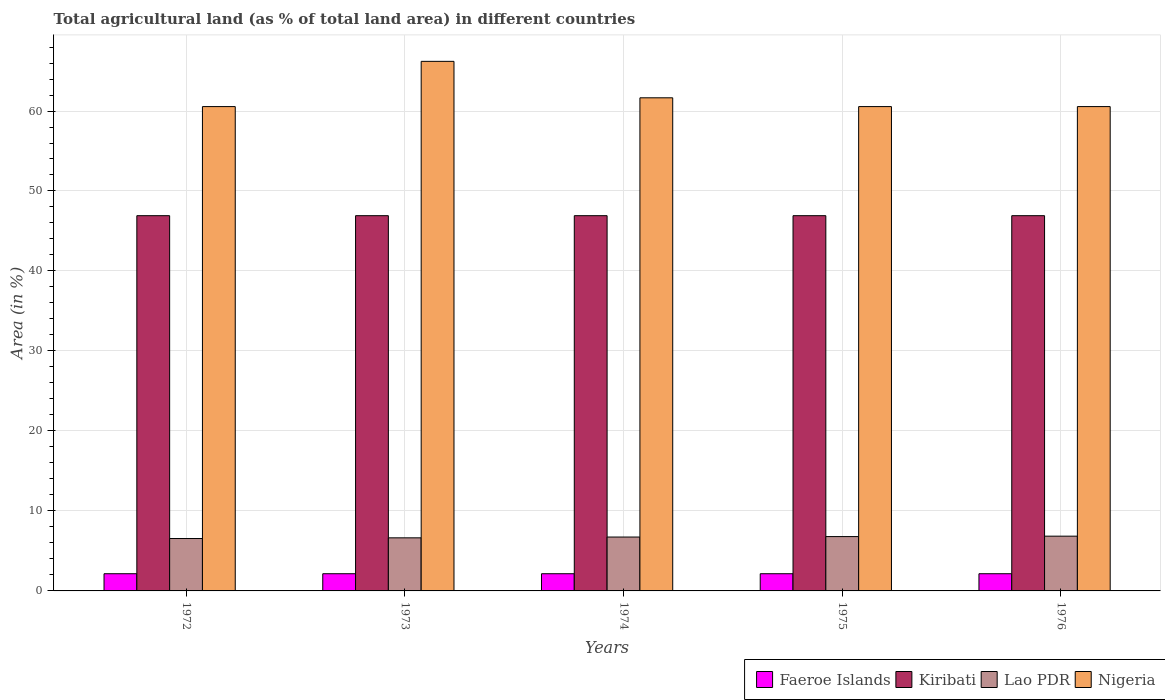How many different coloured bars are there?
Your response must be concise. 4. How many groups of bars are there?
Give a very brief answer. 5. What is the percentage of agricultural land in Lao PDR in 1976?
Provide a succinct answer. 6.85. Across all years, what is the maximum percentage of agricultural land in Faeroe Islands?
Your answer should be compact. 2.15. Across all years, what is the minimum percentage of agricultural land in Lao PDR?
Ensure brevity in your answer.  6.55. In which year was the percentage of agricultural land in Lao PDR maximum?
Provide a short and direct response. 1976. What is the total percentage of agricultural land in Kiribati in the graph?
Make the answer very short. 234.57. What is the difference between the percentage of agricultural land in Lao PDR in 1972 and that in 1976?
Provide a short and direct response. -0.29. What is the difference between the percentage of agricultural land in Kiribati in 1976 and the percentage of agricultural land in Faeroe Islands in 1974?
Provide a succinct answer. 44.76. What is the average percentage of agricultural land in Nigeria per year?
Give a very brief answer. 61.9. In the year 1972, what is the difference between the percentage of agricultural land in Faeroe Islands and percentage of agricultural land in Lao PDR?
Your answer should be compact. -4.4. What is the ratio of the percentage of agricultural land in Lao PDR in 1974 to that in 1976?
Keep it short and to the point. 0.98. Is the percentage of agricultural land in Lao PDR in 1975 less than that in 1976?
Provide a short and direct response. Yes. Is the difference between the percentage of agricultural land in Faeroe Islands in 1972 and 1974 greater than the difference between the percentage of agricultural land in Lao PDR in 1972 and 1974?
Provide a succinct answer. Yes. What is the difference between the highest and the second highest percentage of agricultural land in Lao PDR?
Your response must be concise. 0.05. What is the difference between the highest and the lowest percentage of agricultural land in Kiribati?
Give a very brief answer. 0. In how many years, is the percentage of agricultural land in Kiribati greater than the average percentage of agricultural land in Kiribati taken over all years?
Provide a short and direct response. 0. Is the sum of the percentage of agricultural land in Nigeria in 1973 and 1974 greater than the maximum percentage of agricultural land in Lao PDR across all years?
Provide a short and direct response. Yes. What does the 1st bar from the left in 1972 represents?
Give a very brief answer. Faeroe Islands. What does the 4th bar from the right in 1974 represents?
Your response must be concise. Faeroe Islands. Is it the case that in every year, the sum of the percentage of agricultural land in Lao PDR and percentage of agricultural land in Nigeria is greater than the percentage of agricultural land in Faeroe Islands?
Your response must be concise. Yes. What is the difference between two consecutive major ticks on the Y-axis?
Ensure brevity in your answer.  10. Does the graph contain grids?
Keep it short and to the point. Yes. What is the title of the graph?
Provide a short and direct response. Total agricultural land (as % of total land area) in different countries. What is the label or title of the Y-axis?
Your response must be concise. Area (in %). What is the Area (in %) of Faeroe Islands in 1972?
Make the answer very short. 2.15. What is the Area (in %) of Kiribati in 1972?
Your answer should be very brief. 46.91. What is the Area (in %) of Lao PDR in 1972?
Provide a short and direct response. 6.55. What is the Area (in %) in Nigeria in 1972?
Provide a short and direct response. 60.55. What is the Area (in %) of Faeroe Islands in 1973?
Give a very brief answer. 2.15. What is the Area (in %) of Kiribati in 1973?
Ensure brevity in your answer.  46.91. What is the Area (in %) in Lao PDR in 1973?
Your response must be concise. 6.64. What is the Area (in %) in Nigeria in 1973?
Offer a terse response. 66.21. What is the Area (in %) in Faeroe Islands in 1974?
Provide a short and direct response. 2.15. What is the Area (in %) in Kiribati in 1974?
Your answer should be compact. 46.91. What is the Area (in %) of Lao PDR in 1974?
Offer a terse response. 6.74. What is the Area (in %) of Nigeria in 1974?
Keep it short and to the point. 61.65. What is the Area (in %) in Faeroe Islands in 1975?
Your answer should be very brief. 2.15. What is the Area (in %) in Kiribati in 1975?
Provide a short and direct response. 46.91. What is the Area (in %) of Lao PDR in 1975?
Your answer should be compact. 6.79. What is the Area (in %) in Nigeria in 1975?
Provide a short and direct response. 60.55. What is the Area (in %) in Faeroe Islands in 1976?
Give a very brief answer. 2.15. What is the Area (in %) of Kiribati in 1976?
Your answer should be compact. 46.91. What is the Area (in %) in Lao PDR in 1976?
Your response must be concise. 6.85. What is the Area (in %) of Nigeria in 1976?
Give a very brief answer. 60.55. Across all years, what is the maximum Area (in %) of Faeroe Islands?
Give a very brief answer. 2.15. Across all years, what is the maximum Area (in %) of Kiribati?
Make the answer very short. 46.91. Across all years, what is the maximum Area (in %) in Lao PDR?
Ensure brevity in your answer.  6.85. Across all years, what is the maximum Area (in %) in Nigeria?
Keep it short and to the point. 66.21. Across all years, what is the minimum Area (in %) in Faeroe Islands?
Keep it short and to the point. 2.15. Across all years, what is the minimum Area (in %) in Kiribati?
Keep it short and to the point. 46.91. Across all years, what is the minimum Area (in %) of Lao PDR?
Keep it short and to the point. 6.55. Across all years, what is the minimum Area (in %) in Nigeria?
Provide a succinct answer. 60.55. What is the total Area (in %) of Faeroe Islands in the graph?
Offer a very short reply. 10.74. What is the total Area (in %) of Kiribati in the graph?
Provide a short and direct response. 234.57. What is the total Area (in %) of Lao PDR in the graph?
Offer a very short reply. 33.57. What is the total Area (in %) of Nigeria in the graph?
Provide a short and direct response. 309.52. What is the difference between the Area (in %) in Faeroe Islands in 1972 and that in 1973?
Give a very brief answer. 0. What is the difference between the Area (in %) of Lao PDR in 1972 and that in 1973?
Provide a succinct answer. -0.09. What is the difference between the Area (in %) of Nigeria in 1972 and that in 1973?
Offer a very short reply. -5.65. What is the difference between the Area (in %) of Lao PDR in 1972 and that in 1974?
Offer a terse response. -0.19. What is the difference between the Area (in %) of Nigeria in 1972 and that in 1974?
Offer a very short reply. -1.1. What is the difference between the Area (in %) of Kiribati in 1972 and that in 1975?
Provide a short and direct response. 0. What is the difference between the Area (in %) in Lao PDR in 1972 and that in 1975?
Your response must be concise. -0.24. What is the difference between the Area (in %) in Nigeria in 1972 and that in 1975?
Offer a very short reply. 0. What is the difference between the Area (in %) of Kiribati in 1972 and that in 1976?
Your answer should be very brief. 0. What is the difference between the Area (in %) of Lao PDR in 1972 and that in 1976?
Provide a succinct answer. -0.29. What is the difference between the Area (in %) in Nigeria in 1972 and that in 1976?
Make the answer very short. 0. What is the difference between the Area (in %) of Kiribati in 1973 and that in 1974?
Offer a terse response. 0. What is the difference between the Area (in %) of Lao PDR in 1973 and that in 1974?
Make the answer very short. -0.1. What is the difference between the Area (in %) of Nigeria in 1973 and that in 1974?
Ensure brevity in your answer.  4.56. What is the difference between the Area (in %) of Lao PDR in 1973 and that in 1975?
Your response must be concise. -0.16. What is the difference between the Area (in %) of Nigeria in 1973 and that in 1975?
Offer a very short reply. 5.65. What is the difference between the Area (in %) in Lao PDR in 1973 and that in 1976?
Keep it short and to the point. -0.21. What is the difference between the Area (in %) of Nigeria in 1973 and that in 1976?
Offer a very short reply. 5.65. What is the difference between the Area (in %) of Lao PDR in 1974 and that in 1975?
Offer a terse response. -0.06. What is the difference between the Area (in %) in Nigeria in 1974 and that in 1975?
Offer a terse response. 1.1. What is the difference between the Area (in %) in Faeroe Islands in 1974 and that in 1976?
Your response must be concise. 0. What is the difference between the Area (in %) in Kiribati in 1974 and that in 1976?
Ensure brevity in your answer.  0. What is the difference between the Area (in %) of Lao PDR in 1974 and that in 1976?
Make the answer very short. -0.11. What is the difference between the Area (in %) in Nigeria in 1974 and that in 1976?
Keep it short and to the point. 1.1. What is the difference between the Area (in %) of Kiribati in 1975 and that in 1976?
Offer a very short reply. 0. What is the difference between the Area (in %) in Lao PDR in 1975 and that in 1976?
Keep it short and to the point. -0.05. What is the difference between the Area (in %) in Faeroe Islands in 1972 and the Area (in %) in Kiribati in 1973?
Give a very brief answer. -44.76. What is the difference between the Area (in %) in Faeroe Islands in 1972 and the Area (in %) in Lao PDR in 1973?
Offer a terse response. -4.49. What is the difference between the Area (in %) of Faeroe Islands in 1972 and the Area (in %) of Nigeria in 1973?
Give a very brief answer. -64.06. What is the difference between the Area (in %) in Kiribati in 1972 and the Area (in %) in Lao PDR in 1973?
Give a very brief answer. 40.28. What is the difference between the Area (in %) in Kiribati in 1972 and the Area (in %) in Nigeria in 1973?
Your response must be concise. -19.29. What is the difference between the Area (in %) of Lao PDR in 1972 and the Area (in %) of Nigeria in 1973?
Give a very brief answer. -59.66. What is the difference between the Area (in %) in Faeroe Islands in 1972 and the Area (in %) in Kiribati in 1974?
Provide a succinct answer. -44.76. What is the difference between the Area (in %) of Faeroe Islands in 1972 and the Area (in %) of Lao PDR in 1974?
Your answer should be compact. -4.59. What is the difference between the Area (in %) of Faeroe Islands in 1972 and the Area (in %) of Nigeria in 1974?
Provide a succinct answer. -59.5. What is the difference between the Area (in %) in Kiribati in 1972 and the Area (in %) in Lao PDR in 1974?
Provide a succinct answer. 40.18. What is the difference between the Area (in %) in Kiribati in 1972 and the Area (in %) in Nigeria in 1974?
Your answer should be very brief. -14.74. What is the difference between the Area (in %) in Lao PDR in 1972 and the Area (in %) in Nigeria in 1974?
Provide a succinct answer. -55.1. What is the difference between the Area (in %) in Faeroe Islands in 1972 and the Area (in %) in Kiribati in 1975?
Make the answer very short. -44.76. What is the difference between the Area (in %) in Faeroe Islands in 1972 and the Area (in %) in Lao PDR in 1975?
Keep it short and to the point. -4.64. What is the difference between the Area (in %) of Faeroe Islands in 1972 and the Area (in %) of Nigeria in 1975?
Your answer should be compact. -58.4. What is the difference between the Area (in %) in Kiribati in 1972 and the Area (in %) in Lao PDR in 1975?
Provide a succinct answer. 40.12. What is the difference between the Area (in %) in Kiribati in 1972 and the Area (in %) in Nigeria in 1975?
Offer a terse response. -13.64. What is the difference between the Area (in %) in Lao PDR in 1972 and the Area (in %) in Nigeria in 1975?
Keep it short and to the point. -54. What is the difference between the Area (in %) of Faeroe Islands in 1972 and the Area (in %) of Kiribati in 1976?
Offer a very short reply. -44.76. What is the difference between the Area (in %) in Faeroe Islands in 1972 and the Area (in %) in Lao PDR in 1976?
Ensure brevity in your answer.  -4.7. What is the difference between the Area (in %) of Faeroe Islands in 1972 and the Area (in %) of Nigeria in 1976?
Give a very brief answer. -58.4. What is the difference between the Area (in %) of Kiribati in 1972 and the Area (in %) of Lao PDR in 1976?
Your response must be concise. 40.07. What is the difference between the Area (in %) in Kiribati in 1972 and the Area (in %) in Nigeria in 1976?
Your answer should be very brief. -13.64. What is the difference between the Area (in %) in Lao PDR in 1972 and the Area (in %) in Nigeria in 1976?
Your answer should be compact. -54. What is the difference between the Area (in %) of Faeroe Islands in 1973 and the Area (in %) of Kiribati in 1974?
Give a very brief answer. -44.76. What is the difference between the Area (in %) in Faeroe Islands in 1973 and the Area (in %) in Lao PDR in 1974?
Give a very brief answer. -4.59. What is the difference between the Area (in %) in Faeroe Islands in 1973 and the Area (in %) in Nigeria in 1974?
Your answer should be very brief. -59.5. What is the difference between the Area (in %) of Kiribati in 1973 and the Area (in %) of Lao PDR in 1974?
Provide a succinct answer. 40.18. What is the difference between the Area (in %) of Kiribati in 1973 and the Area (in %) of Nigeria in 1974?
Your response must be concise. -14.74. What is the difference between the Area (in %) in Lao PDR in 1973 and the Area (in %) in Nigeria in 1974?
Give a very brief answer. -55.01. What is the difference between the Area (in %) in Faeroe Islands in 1973 and the Area (in %) in Kiribati in 1975?
Make the answer very short. -44.76. What is the difference between the Area (in %) of Faeroe Islands in 1973 and the Area (in %) of Lao PDR in 1975?
Your answer should be compact. -4.64. What is the difference between the Area (in %) in Faeroe Islands in 1973 and the Area (in %) in Nigeria in 1975?
Make the answer very short. -58.4. What is the difference between the Area (in %) of Kiribati in 1973 and the Area (in %) of Lao PDR in 1975?
Offer a terse response. 40.12. What is the difference between the Area (in %) in Kiribati in 1973 and the Area (in %) in Nigeria in 1975?
Keep it short and to the point. -13.64. What is the difference between the Area (in %) of Lao PDR in 1973 and the Area (in %) of Nigeria in 1975?
Your answer should be very brief. -53.92. What is the difference between the Area (in %) of Faeroe Islands in 1973 and the Area (in %) of Kiribati in 1976?
Your response must be concise. -44.76. What is the difference between the Area (in %) in Faeroe Islands in 1973 and the Area (in %) in Lao PDR in 1976?
Provide a short and direct response. -4.7. What is the difference between the Area (in %) in Faeroe Islands in 1973 and the Area (in %) in Nigeria in 1976?
Give a very brief answer. -58.4. What is the difference between the Area (in %) in Kiribati in 1973 and the Area (in %) in Lao PDR in 1976?
Your response must be concise. 40.07. What is the difference between the Area (in %) of Kiribati in 1973 and the Area (in %) of Nigeria in 1976?
Provide a short and direct response. -13.64. What is the difference between the Area (in %) of Lao PDR in 1973 and the Area (in %) of Nigeria in 1976?
Ensure brevity in your answer.  -53.92. What is the difference between the Area (in %) in Faeroe Islands in 1974 and the Area (in %) in Kiribati in 1975?
Your response must be concise. -44.76. What is the difference between the Area (in %) in Faeroe Islands in 1974 and the Area (in %) in Lao PDR in 1975?
Offer a very short reply. -4.64. What is the difference between the Area (in %) in Faeroe Islands in 1974 and the Area (in %) in Nigeria in 1975?
Keep it short and to the point. -58.4. What is the difference between the Area (in %) in Kiribati in 1974 and the Area (in %) in Lao PDR in 1975?
Your response must be concise. 40.12. What is the difference between the Area (in %) in Kiribati in 1974 and the Area (in %) in Nigeria in 1975?
Provide a short and direct response. -13.64. What is the difference between the Area (in %) of Lao PDR in 1974 and the Area (in %) of Nigeria in 1975?
Ensure brevity in your answer.  -53.82. What is the difference between the Area (in %) of Faeroe Islands in 1974 and the Area (in %) of Kiribati in 1976?
Keep it short and to the point. -44.76. What is the difference between the Area (in %) in Faeroe Islands in 1974 and the Area (in %) in Lao PDR in 1976?
Provide a short and direct response. -4.7. What is the difference between the Area (in %) of Faeroe Islands in 1974 and the Area (in %) of Nigeria in 1976?
Keep it short and to the point. -58.4. What is the difference between the Area (in %) of Kiribati in 1974 and the Area (in %) of Lao PDR in 1976?
Provide a succinct answer. 40.07. What is the difference between the Area (in %) of Kiribati in 1974 and the Area (in %) of Nigeria in 1976?
Make the answer very short. -13.64. What is the difference between the Area (in %) of Lao PDR in 1974 and the Area (in %) of Nigeria in 1976?
Ensure brevity in your answer.  -53.82. What is the difference between the Area (in %) of Faeroe Islands in 1975 and the Area (in %) of Kiribati in 1976?
Ensure brevity in your answer.  -44.76. What is the difference between the Area (in %) in Faeroe Islands in 1975 and the Area (in %) in Lao PDR in 1976?
Your response must be concise. -4.7. What is the difference between the Area (in %) of Faeroe Islands in 1975 and the Area (in %) of Nigeria in 1976?
Offer a very short reply. -58.4. What is the difference between the Area (in %) of Kiribati in 1975 and the Area (in %) of Lao PDR in 1976?
Your response must be concise. 40.07. What is the difference between the Area (in %) of Kiribati in 1975 and the Area (in %) of Nigeria in 1976?
Give a very brief answer. -13.64. What is the difference between the Area (in %) of Lao PDR in 1975 and the Area (in %) of Nigeria in 1976?
Provide a short and direct response. -53.76. What is the average Area (in %) in Faeroe Islands per year?
Give a very brief answer. 2.15. What is the average Area (in %) in Kiribati per year?
Your answer should be very brief. 46.91. What is the average Area (in %) in Lao PDR per year?
Your answer should be very brief. 6.71. What is the average Area (in %) in Nigeria per year?
Offer a very short reply. 61.9. In the year 1972, what is the difference between the Area (in %) in Faeroe Islands and Area (in %) in Kiribati?
Give a very brief answer. -44.76. In the year 1972, what is the difference between the Area (in %) in Faeroe Islands and Area (in %) in Lao PDR?
Your answer should be compact. -4.4. In the year 1972, what is the difference between the Area (in %) in Faeroe Islands and Area (in %) in Nigeria?
Offer a very short reply. -58.4. In the year 1972, what is the difference between the Area (in %) of Kiribati and Area (in %) of Lao PDR?
Your answer should be compact. 40.36. In the year 1972, what is the difference between the Area (in %) of Kiribati and Area (in %) of Nigeria?
Give a very brief answer. -13.64. In the year 1972, what is the difference between the Area (in %) of Lao PDR and Area (in %) of Nigeria?
Provide a succinct answer. -54. In the year 1973, what is the difference between the Area (in %) in Faeroe Islands and Area (in %) in Kiribati?
Make the answer very short. -44.76. In the year 1973, what is the difference between the Area (in %) of Faeroe Islands and Area (in %) of Lao PDR?
Your response must be concise. -4.49. In the year 1973, what is the difference between the Area (in %) in Faeroe Islands and Area (in %) in Nigeria?
Your answer should be compact. -64.06. In the year 1973, what is the difference between the Area (in %) in Kiribati and Area (in %) in Lao PDR?
Your answer should be compact. 40.28. In the year 1973, what is the difference between the Area (in %) of Kiribati and Area (in %) of Nigeria?
Ensure brevity in your answer.  -19.29. In the year 1973, what is the difference between the Area (in %) in Lao PDR and Area (in %) in Nigeria?
Ensure brevity in your answer.  -59.57. In the year 1974, what is the difference between the Area (in %) in Faeroe Islands and Area (in %) in Kiribati?
Offer a terse response. -44.76. In the year 1974, what is the difference between the Area (in %) in Faeroe Islands and Area (in %) in Lao PDR?
Provide a short and direct response. -4.59. In the year 1974, what is the difference between the Area (in %) of Faeroe Islands and Area (in %) of Nigeria?
Your answer should be very brief. -59.5. In the year 1974, what is the difference between the Area (in %) of Kiribati and Area (in %) of Lao PDR?
Provide a short and direct response. 40.18. In the year 1974, what is the difference between the Area (in %) of Kiribati and Area (in %) of Nigeria?
Offer a terse response. -14.74. In the year 1974, what is the difference between the Area (in %) in Lao PDR and Area (in %) in Nigeria?
Make the answer very short. -54.91. In the year 1975, what is the difference between the Area (in %) of Faeroe Islands and Area (in %) of Kiribati?
Keep it short and to the point. -44.76. In the year 1975, what is the difference between the Area (in %) in Faeroe Islands and Area (in %) in Lao PDR?
Ensure brevity in your answer.  -4.64. In the year 1975, what is the difference between the Area (in %) of Faeroe Islands and Area (in %) of Nigeria?
Your answer should be very brief. -58.4. In the year 1975, what is the difference between the Area (in %) of Kiribati and Area (in %) of Lao PDR?
Keep it short and to the point. 40.12. In the year 1975, what is the difference between the Area (in %) in Kiribati and Area (in %) in Nigeria?
Your response must be concise. -13.64. In the year 1975, what is the difference between the Area (in %) of Lao PDR and Area (in %) of Nigeria?
Ensure brevity in your answer.  -53.76. In the year 1976, what is the difference between the Area (in %) of Faeroe Islands and Area (in %) of Kiribati?
Offer a very short reply. -44.76. In the year 1976, what is the difference between the Area (in %) in Faeroe Islands and Area (in %) in Lao PDR?
Your answer should be compact. -4.7. In the year 1976, what is the difference between the Area (in %) in Faeroe Islands and Area (in %) in Nigeria?
Give a very brief answer. -58.4. In the year 1976, what is the difference between the Area (in %) in Kiribati and Area (in %) in Lao PDR?
Offer a terse response. 40.07. In the year 1976, what is the difference between the Area (in %) of Kiribati and Area (in %) of Nigeria?
Your response must be concise. -13.64. In the year 1976, what is the difference between the Area (in %) of Lao PDR and Area (in %) of Nigeria?
Provide a succinct answer. -53.71. What is the ratio of the Area (in %) of Lao PDR in 1972 to that in 1973?
Keep it short and to the point. 0.99. What is the ratio of the Area (in %) of Nigeria in 1972 to that in 1973?
Your answer should be compact. 0.91. What is the ratio of the Area (in %) in Kiribati in 1972 to that in 1974?
Offer a very short reply. 1. What is the ratio of the Area (in %) in Lao PDR in 1972 to that in 1974?
Your answer should be compact. 0.97. What is the ratio of the Area (in %) of Nigeria in 1972 to that in 1974?
Your answer should be very brief. 0.98. What is the ratio of the Area (in %) of Faeroe Islands in 1972 to that in 1975?
Ensure brevity in your answer.  1. What is the ratio of the Area (in %) in Kiribati in 1972 to that in 1975?
Offer a terse response. 1. What is the ratio of the Area (in %) in Lao PDR in 1972 to that in 1975?
Keep it short and to the point. 0.96. What is the ratio of the Area (in %) in Nigeria in 1972 to that in 1975?
Give a very brief answer. 1. What is the ratio of the Area (in %) in Lao PDR in 1973 to that in 1974?
Offer a terse response. 0.99. What is the ratio of the Area (in %) of Nigeria in 1973 to that in 1974?
Give a very brief answer. 1.07. What is the ratio of the Area (in %) in Nigeria in 1973 to that in 1975?
Your response must be concise. 1.09. What is the ratio of the Area (in %) in Lao PDR in 1973 to that in 1976?
Provide a succinct answer. 0.97. What is the ratio of the Area (in %) of Nigeria in 1973 to that in 1976?
Provide a short and direct response. 1.09. What is the ratio of the Area (in %) in Faeroe Islands in 1974 to that in 1975?
Provide a short and direct response. 1. What is the ratio of the Area (in %) of Lao PDR in 1974 to that in 1975?
Give a very brief answer. 0.99. What is the ratio of the Area (in %) of Nigeria in 1974 to that in 1975?
Ensure brevity in your answer.  1.02. What is the ratio of the Area (in %) in Faeroe Islands in 1974 to that in 1976?
Your answer should be very brief. 1. What is the ratio of the Area (in %) in Lao PDR in 1974 to that in 1976?
Provide a succinct answer. 0.98. What is the ratio of the Area (in %) of Nigeria in 1974 to that in 1976?
Offer a very short reply. 1.02. What is the ratio of the Area (in %) in Kiribati in 1975 to that in 1976?
Your answer should be very brief. 1. What is the difference between the highest and the second highest Area (in %) in Lao PDR?
Your answer should be compact. 0.05. What is the difference between the highest and the second highest Area (in %) of Nigeria?
Offer a terse response. 4.56. What is the difference between the highest and the lowest Area (in %) in Faeroe Islands?
Provide a short and direct response. 0. What is the difference between the highest and the lowest Area (in %) in Kiribati?
Ensure brevity in your answer.  0. What is the difference between the highest and the lowest Area (in %) in Lao PDR?
Offer a terse response. 0.29. What is the difference between the highest and the lowest Area (in %) in Nigeria?
Offer a terse response. 5.65. 